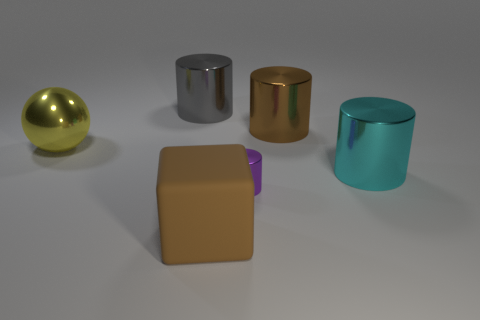There is a metal thing that is the same color as the large matte block; what shape is it?
Offer a very short reply. Cylinder. Is the shape of the big brown thing behind the block the same as the big metallic object that is in front of the metallic sphere?
Offer a terse response. Yes. There is a small purple thing that is the same shape as the big brown shiny thing; what is it made of?
Offer a terse response. Metal. What color is the thing that is both on the left side of the small cylinder and in front of the cyan metallic thing?
Provide a short and direct response. Brown. Are there any large yellow objects that are on the right side of the large brown thing that is right of the large brown thing that is on the left side of the purple cylinder?
Your response must be concise. No. What number of things are either spheres or large gray metallic cylinders?
Your answer should be compact. 2. Are the tiny cylinder and the large brown thing in front of the yellow shiny ball made of the same material?
Make the answer very short. No. Are there any other things that are the same color as the cube?
Give a very brief answer. Yes. What number of objects are large things behind the matte thing or things that are in front of the large sphere?
Provide a succinct answer. 6. What is the shape of the metal object that is both left of the brown cylinder and in front of the big yellow metal object?
Offer a terse response. Cylinder. 